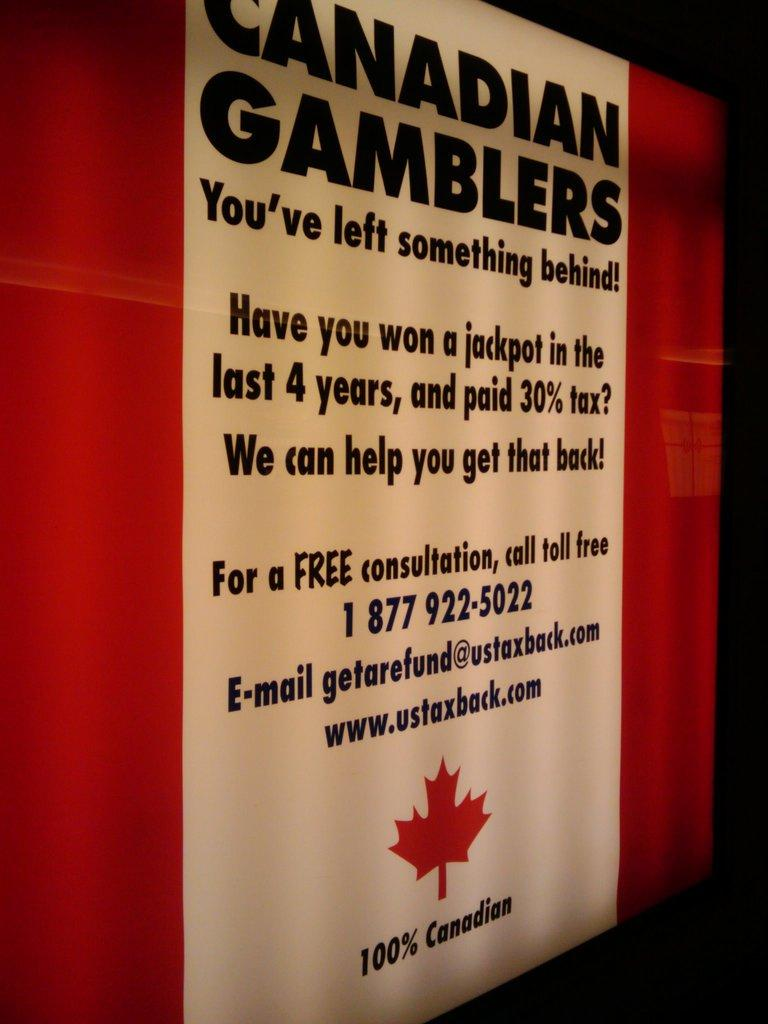<image>
Create a compact narrative representing the image presented. A poster tells Canadian gamblers that they can get some of their tax payments back. 